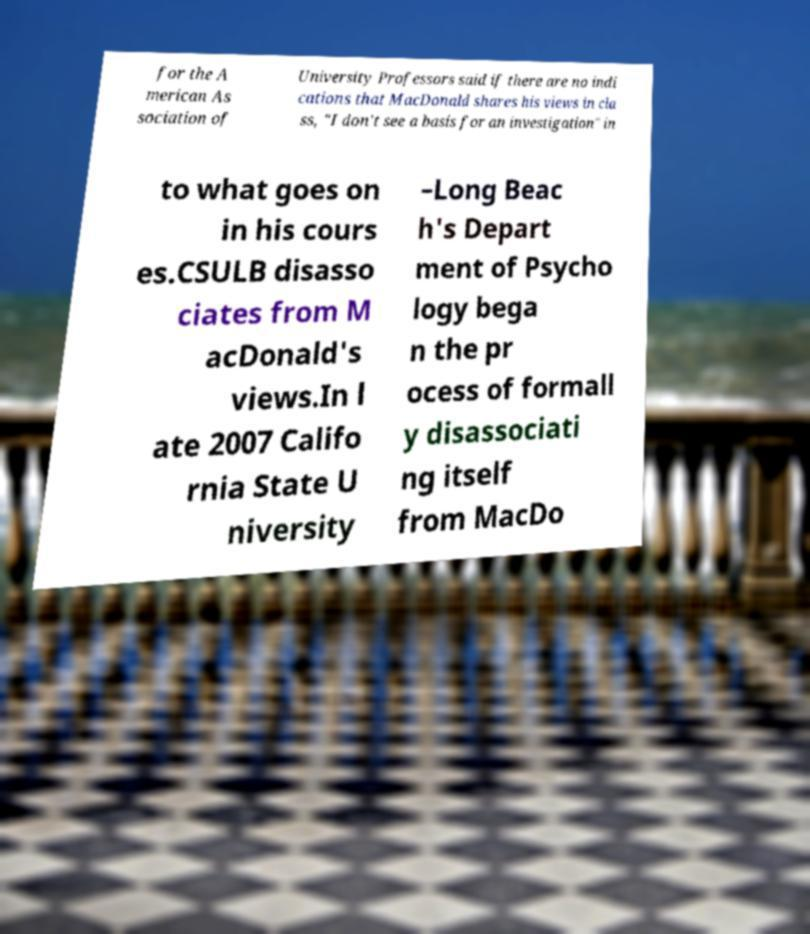Could you extract and type out the text from this image? for the A merican As sociation of University Professors said if there are no indi cations that MacDonald shares his views in cla ss, "I don't see a basis for an investigation" in to what goes on in his cours es.CSULB disasso ciates from M acDonald's views.In l ate 2007 Califo rnia State U niversity –Long Beac h's Depart ment of Psycho logy bega n the pr ocess of formall y disassociati ng itself from MacDo 